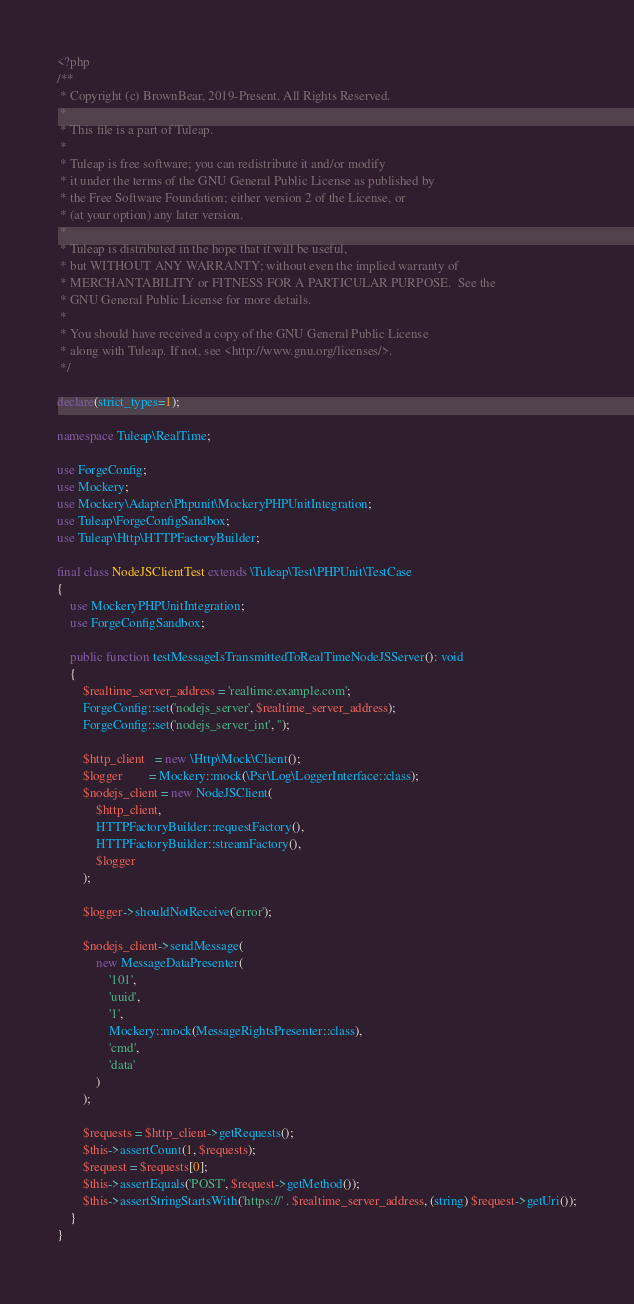Convert code to text. <code><loc_0><loc_0><loc_500><loc_500><_PHP_><?php
/**
 * Copyright (c) BrownBear, 2019-Present. All Rights Reserved.
 *
 * This file is a part of Tuleap.
 *
 * Tuleap is free software; you can redistribute it and/or modify
 * it under the terms of the GNU General Public License as published by
 * the Free Software Foundation; either version 2 of the License, or
 * (at your option) any later version.
 *
 * Tuleap is distributed in the hope that it will be useful,
 * but WITHOUT ANY WARRANTY; without even the implied warranty of
 * MERCHANTABILITY or FITNESS FOR A PARTICULAR PURPOSE.  See the
 * GNU General Public License for more details.
 *
 * You should have received a copy of the GNU General Public License
 * along with Tuleap. If not, see <http://www.gnu.org/licenses/>.
 */

declare(strict_types=1);

namespace Tuleap\RealTime;

use ForgeConfig;
use Mockery;
use Mockery\Adapter\Phpunit\MockeryPHPUnitIntegration;
use Tuleap\ForgeConfigSandbox;
use Tuleap\Http\HTTPFactoryBuilder;

final class NodeJSClientTest extends \Tuleap\Test\PHPUnit\TestCase
{
    use MockeryPHPUnitIntegration;
    use ForgeConfigSandbox;

    public function testMessageIsTransmittedToRealTimeNodeJSServer(): void
    {
        $realtime_server_address = 'realtime.example.com';
        ForgeConfig::set('nodejs_server', $realtime_server_address);
        ForgeConfig::set('nodejs_server_int', '');

        $http_client   = new \Http\Mock\Client();
        $logger        = Mockery::mock(\Psr\Log\LoggerInterface::class);
        $nodejs_client = new NodeJSClient(
            $http_client,
            HTTPFactoryBuilder::requestFactory(),
            HTTPFactoryBuilder::streamFactory(),
            $logger
        );

        $logger->shouldNotReceive('error');

        $nodejs_client->sendMessage(
            new MessageDataPresenter(
                '101',
                'uuid',
                '1',
                Mockery::mock(MessageRightsPresenter::class),
                'cmd',
                'data'
            )
        );

        $requests = $http_client->getRequests();
        $this->assertCount(1, $requests);
        $request = $requests[0];
        $this->assertEquals('POST', $request->getMethod());
        $this->assertStringStartsWith('https://' . $realtime_server_address, (string) $request->getUri());
    }
}
</code> 